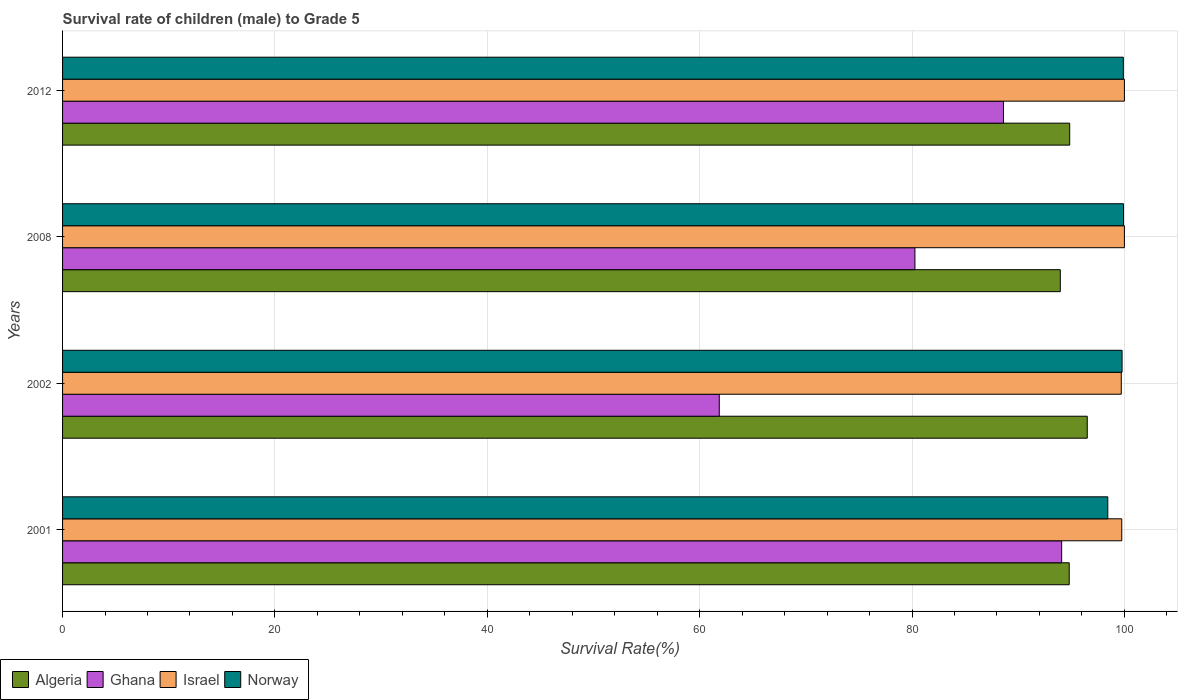Are the number of bars per tick equal to the number of legend labels?
Offer a terse response. Yes. How many bars are there on the 1st tick from the top?
Offer a very short reply. 4. How many bars are there on the 2nd tick from the bottom?
Keep it short and to the point. 4. In how many cases, is the number of bars for a given year not equal to the number of legend labels?
Your response must be concise. 0. What is the survival rate of male children to grade 5 in Norway in 2012?
Keep it short and to the point. 99.9. Across all years, what is the maximum survival rate of male children to grade 5 in Algeria?
Your response must be concise. 96.5. Across all years, what is the minimum survival rate of male children to grade 5 in Israel?
Give a very brief answer. 99.71. What is the total survival rate of male children to grade 5 in Israel in the graph?
Keep it short and to the point. 399.46. What is the difference between the survival rate of male children to grade 5 in Israel in 2008 and that in 2012?
Offer a very short reply. 0. What is the difference between the survival rate of male children to grade 5 in Norway in 2001 and the survival rate of male children to grade 5 in Ghana in 2012?
Provide a succinct answer. 9.83. What is the average survival rate of male children to grade 5 in Ghana per year?
Keep it short and to the point. 81.21. In the year 2008, what is the difference between the survival rate of male children to grade 5 in Ghana and survival rate of male children to grade 5 in Norway?
Provide a succinct answer. -19.65. In how many years, is the survival rate of male children to grade 5 in Algeria greater than 16 %?
Offer a very short reply. 4. What is the ratio of the survival rate of male children to grade 5 in Ghana in 2001 to that in 2002?
Offer a terse response. 1.52. Is the survival rate of male children to grade 5 in Ghana in 2001 less than that in 2002?
Ensure brevity in your answer.  No. What is the difference between the highest and the second highest survival rate of male children to grade 5 in Ghana?
Provide a short and direct response. 5.48. What is the difference between the highest and the lowest survival rate of male children to grade 5 in Algeria?
Offer a terse response. 2.54. Is it the case that in every year, the sum of the survival rate of male children to grade 5 in Algeria and survival rate of male children to grade 5 in Israel is greater than the sum of survival rate of male children to grade 5 in Norway and survival rate of male children to grade 5 in Ghana?
Keep it short and to the point. No. Is it the case that in every year, the sum of the survival rate of male children to grade 5 in Israel and survival rate of male children to grade 5 in Norway is greater than the survival rate of male children to grade 5 in Algeria?
Offer a very short reply. Yes. How many years are there in the graph?
Provide a succinct answer. 4. What is the difference between two consecutive major ticks on the X-axis?
Keep it short and to the point. 20. Does the graph contain any zero values?
Your answer should be compact. No. Does the graph contain grids?
Provide a short and direct response. Yes. Where does the legend appear in the graph?
Offer a very short reply. Bottom left. What is the title of the graph?
Your answer should be compact. Survival rate of children (male) to Grade 5. What is the label or title of the X-axis?
Provide a short and direct response. Survival Rate(%). What is the label or title of the Y-axis?
Your answer should be compact. Years. What is the Survival Rate(%) of Algeria in 2001?
Offer a very short reply. 94.8. What is the Survival Rate(%) in Ghana in 2001?
Provide a succinct answer. 94.09. What is the Survival Rate(%) of Israel in 2001?
Give a very brief answer. 99.75. What is the Survival Rate(%) in Norway in 2001?
Offer a terse response. 98.44. What is the Survival Rate(%) in Algeria in 2002?
Your answer should be compact. 96.5. What is the Survival Rate(%) of Ghana in 2002?
Give a very brief answer. 61.85. What is the Survival Rate(%) of Israel in 2002?
Offer a very short reply. 99.71. What is the Survival Rate(%) in Norway in 2002?
Your answer should be very brief. 99.78. What is the Survival Rate(%) in Algeria in 2008?
Your answer should be very brief. 93.96. What is the Survival Rate(%) of Ghana in 2008?
Keep it short and to the point. 80.27. What is the Survival Rate(%) of Norway in 2008?
Provide a short and direct response. 99.92. What is the Survival Rate(%) in Algeria in 2012?
Your answer should be compact. 94.85. What is the Survival Rate(%) in Ghana in 2012?
Provide a succinct answer. 88.61. What is the Survival Rate(%) of Norway in 2012?
Ensure brevity in your answer.  99.9. Across all years, what is the maximum Survival Rate(%) in Algeria?
Your answer should be very brief. 96.5. Across all years, what is the maximum Survival Rate(%) of Ghana?
Provide a succinct answer. 94.09. Across all years, what is the maximum Survival Rate(%) in Israel?
Give a very brief answer. 100. Across all years, what is the maximum Survival Rate(%) in Norway?
Offer a terse response. 99.92. Across all years, what is the minimum Survival Rate(%) in Algeria?
Provide a short and direct response. 93.96. Across all years, what is the minimum Survival Rate(%) of Ghana?
Make the answer very short. 61.85. Across all years, what is the minimum Survival Rate(%) in Israel?
Ensure brevity in your answer.  99.71. Across all years, what is the minimum Survival Rate(%) of Norway?
Your answer should be compact. 98.44. What is the total Survival Rate(%) of Algeria in the graph?
Provide a succinct answer. 380.12. What is the total Survival Rate(%) of Ghana in the graph?
Offer a terse response. 324.82. What is the total Survival Rate(%) in Israel in the graph?
Make the answer very short. 399.46. What is the total Survival Rate(%) in Norway in the graph?
Offer a terse response. 398.04. What is the difference between the Survival Rate(%) in Algeria in 2001 and that in 2002?
Your answer should be very brief. -1.7. What is the difference between the Survival Rate(%) of Ghana in 2001 and that in 2002?
Provide a short and direct response. 32.24. What is the difference between the Survival Rate(%) of Israel in 2001 and that in 2002?
Your answer should be compact. 0.05. What is the difference between the Survival Rate(%) of Norway in 2001 and that in 2002?
Give a very brief answer. -1.34. What is the difference between the Survival Rate(%) of Algeria in 2001 and that in 2008?
Offer a terse response. 0.84. What is the difference between the Survival Rate(%) of Ghana in 2001 and that in 2008?
Provide a succinct answer. 13.82. What is the difference between the Survival Rate(%) of Israel in 2001 and that in 2008?
Keep it short and to the point. -0.25. What is the difference between the Survival Rate(%) of Norway in 2001 and that in 2008?
Ensure brevity in your answer.  -1.48. What is the difference between the Survival Rate(%) of Algeria in 2001 and that in 2012?
Your response must be concise. -0.05. What is the difference between the Survival Rate(%) of Ghana in 2001 and that in 2012?
Ensure brevity in your answer.  5.48. What is the difference between the Survival Rate(%) in Israel in 2001 and that in 2012?
Offer a very short reply. -0.25. What is the difference between the Survival Rate(%) in Norway in 2001 and that in 2012?
Give a very brief answer. -1.46. What is the difference between the Survival Rate(%) in Algeria in 2002 and that in 2008?
Your answer should be very brief. 2.54. What is the difference between the Survival Rate(%) in Ghana in 2002 and that in 2008?
Your answer should be compact. -18.42. What is the difference between the Survival Rate(%) of Israel in 2002 and that in 2008?
Make the answer very short. -0.29. What is the difference between the Survival Rate(%) of Norway in 2002 and that in 2008?
Your answer should be compact. -0.14. What is the difference between the Survival Rate(%) of Algeria in 2002 and that in 2012?
Provide a short and direct response. 1.65. What is the difference between the Survival Rate(%) in Ghana in 2002 and that in 2012?
Your answer should be very brief. -26.76. What is the difference between the Survival Rate(%) of Israel in 2002 and that in 2012?
Your answer should be very brief. -0.29. What is the difference between the Survival Rate(%) of Norway in 2002 and that in 2012?
Ensure brevity in your answer.  -0.12. What is the difference between the Survival Rate(%) in Algeria in 2008 and that in 2012?
Provide a short and direct response. -0.89. What is the difference between the Survival Rate(%) of Ghana in 2008 and that in 2012?
Provide a succinct answer. -8.34. What is the difference between the Survival Rate(%) of Norway in 2008 and that in 2012?
Your answer should be compact. 0.02. What is the difference between the Survival Rate(%) in Algeria in 2001 and the Survival Rate(%) in Ghana in 2002?
Provide a short and direct response. 32.96. What is the difference between the Survival Rate(%) of Algeria in 2001 and the Survival Rate(%) of Israel in 2002?
Your answer should be compact. -4.9. What is the difference between the Survival Rate(%) in Algeria in 2001 and the Survival Rate(%) in Norway in 2002?
Make the answer very short. -4.98. What is the difference between the Survival Rate(%) of Ghana in 2001 and the Survival Rate(%) of Israel in 2002?
Provide a short and direct response. -5.61. What is the difference between the Survival Rate(%) in Ghana in 2001 and the Survival Rate(%) in Norway in 2002?
Give a very brief answer. -5.69. What is the difference between the Survival Rate(%) of Israel in 2001 and the Survival Rate(%) of Norway in 2002?
Give a very brief answer. -0.03. What is the difference between the Survival Rate(%) in Algeria in 2001 and the Survival Rate(%) in Ghana in 2008?
Make the answer very short. 14.53. What is the difference between the Survival Rate(%) of Algeria in 2001 and the Survival Rate(%) of Israel in 2008?
Provide a short and direct response. -5.2. What is the difference between the Survival Rate(%) of Algeria in 2001 and the Survival Rate(%) of Norway in 2008?
Provide a succinct answer. -5.11. What is the difference between the Survival Rate(%) of Ghana in 2001 and the Survival Rate(%) of Israel in 2008?
Your response must be concise. -5.91. What is the difference between the Survival Rate(%) in Ghana in 2001 and the Survival Rate(%) in Norway in 2008?
Ensure brevity in your answer.  -5.83. What is the difference between the Survival Rate(%) of Israel in 2001 and the Survival Rate(%) of Norway in 2008?
Ensure brevity in your answer.  -0.17. What is the difference between the Survival Rate(%) of Algeria in 2001 and the Survival Rate(%) of Ghana in 2012?
Provide a succinct answer. 6.19. What is the difference between the Survival Rate(%) of Algeria in 2001 and the Survival Rate(%) of Israel in 2012?
Give a very brief answer. -5.2. What is the difference between the Survival Rate(%) of Algeria in 2001 and the Survival Rate(%) of Norway in 2012?
Ensure brevity in your answer.  -5.1. What is the difference between the Survival Rate(%) of Ghana in 2001 and the Survival Rate(%) of Israel in 2012?
Offer a terse response. -5.91. What is the difference between the Survival Rate(%) of Ghana in 2001 and the Survival Rate(%) of Norway in 2012?
Keep it short and to the point. -5.81. What is the difference between the Survival Rate(%) in Israel in 2001 and the Survival Rate(%) in Norway in 2012?
Offer a terse response. -0.15. What is the difference between the Survival Rate(%) in Algeria in 2002 and the Survival Rate(%) in Ghana in 2008?
Ensure brevity in your answer.  16.23. What is the difference between the Survival Rate(%) of Algeria in 2002 and the Survival Rate(%) of Israel in 2008?
Your answer should be very brief. -3.5. What is the difference between the Survival Rate(%) of Algeria in 2002 and the Survival Rate(%) of Norway in 2008?
Your answer should be very brief. -3.42. What is the difference between the Survival Rate(%) in Ghana in 2002 and the Survival Rate(%) in Israel in 2008?
Keep it short and to the point. -38.15. What is the difference between the Survival Rate(%) in Ghana in 2002 and the Survival Rate(%) in Norway in 2008?
Ensure brevity in your answer.  -38.07. What is the difference between the Survival Rate(%) of Israel in 2002 and the Survival Rate(%) of Norway in 2008?
Offer a terse response. -0.21. What is the difference between the Survival Rate(%) of Algeria in 2002 and the Survival Rate(%) of Ghana in 2012?
Keep it short and to the point. 7.89. What is the difference between the Survival Rate(%) of Algeria in 2002 and the Survival Rate(%) of Israel in 2012?
Your response must be concise. -3.5. What is the difference between the Survival Rate(%) of Algeria in 2002 and the Survival Rate(%) of Norway in 2012?
Provide a succinct answer. -3.4. What is the difference between the Survival Rate(%) of Ghana in 2002 and the Survival Rate(%) of Israel in 2012?
Make the answer very short. -38.15. What is the difference between the Survival Rate(%) in Ghana in 2002 and the Survival Rate(%) in Norway in 2012?
Your answer should be very brief. -38.05. What is the difference between the Survival Rate(%) of Israel in 2002 and the Survival Rate(%) of Norway in 2012?
Your response must be concise. -0.19. What is the difference between the Survival Rate(%) in Algeria in 2008 and the Survival Rate(%) in Ghana in 2012?
Keep it short and to the point. 5.35. What is the difference between the Survival Rate(%) in Algeria in 2008 and the Survival Rate(%) in Israel in 2012?
Your response must be concise. -6.04. What is the difference between the Survival Rate(%) of Algeria in 2008 and the Survival Rate(%) of Norway in 2012?
Make the answer very short. -5.94. What is the difference between the Survival Rate(%) of Ghana in 2008 and the Survival Rate(%) of Israel in 2012?
Offer a terse response. -19.73. What is the difference between the Survival Rate(%) of Ghana in 2008 and the Survival Rate(%) of Norway in 2012?
Provide a short and direct response. -19.63. What is the difference between the Survival Rate(%) in Israel in 2008 and the Survival Rate(%) in Norway in 2012?
Give a very brief answer. 0.1. What is the average Survival Rate(%) in Algeria per year?
Make the answer very short. 95.03. What is the average Survival Rate(%) of Ghana per year?
Your answer should be compact. 81.21. What is the average Survival Rate(%) in Israel per year?
Make the answer very short. 99.86. What is the average Survival Rate(%) in Norway per year?
Make the answer very short. 99.51. In the year 2001, what is the difference between the Survival Rate(%) in Algeria and Survival Rate(%) in Ghana?
Offer a very short reply. 0.71. In the year 2001, what is the difference between the Survival Rate(%) of Algeria and Survival Rate(%) of Israel?
Your answer should be compact. -4.95. In the year 2001, what is the difference between the Survival Rate(%) in Algeria and Survival Rate(%) in Norway?
Provide a succinct answer. -3.63. In the year 2001, what is the difference between the Survival Rate(%) of Ghana and Survival Rate(%) of Israel?
Keep it short and to the point. -5.66. In the year 2001, what is the difference between the Survival Rate(%) of Ghana and Survival Rate(%) of Norway?
Your response must be concise. -4.35. In the year 2001, what is the difference between the Survival Rate(%) in Israel and Survival Rate(%) in Norway?
Provide a succinct answer. 1.31. In the year 2002, what is the difference between the Survival Rate(%) in Algeria and Survival Rate(%) in Ghana?
Provide a short and direct response. 34.65. In the year 2002, what is the difference between the Survival Rate(%) of Algeria and Survival Rate(%) of Israel?
Your answer should be very brief. -3.2. In the year 2002, what is the difference between the Survival Rate(%) of Algeria and Survival Rate(%) of Norway?
Give a very brief answer. -3.28. In the year 2002, what is the difference between the Survival Rate(%) of Ghana and Survival Rate(%) of Israel?
Offer a very short reply. -37.86. In the year 2002, what is the difference between the Survival Rate(%) in Ghana and Survival Rate(%) in Norway?
Give a very brief answer. -37.93. In the year 2002, what is the difference between the Survival Rate(%) in Israel and Survival Rate(%) in Norway?
Your answer should be compact. -0.07. In the year 2008, what is the difference between the Survival Rate(%) of Algeria and Survival Rate(%) of Ghana?
Keep it short and to the point. 13.69. In the year 2008, what is the difference between the Survival Rate(%) of Algeria and Survival Rate(%) of Israel?
Offer a very short reply. -6.04. In the year 2008, what is the difference between the Survival Rate(%) in Algeria and Survival Rate(%) in Norway?
Provide a succinct answer. -5.95. In the year 2008, what is the difference between the Survival Rate(%) in Ghana and Survival Rate(%) in Israel?
Offer a very short reply. -19.73. In the year 2008, what is the difference between the Survival Rate(%) in Ghana and Survival Rate(%) in Norway?
Offer a terse response. -19.65. In the year 2008, what is the difference between the Survival Rate(%) of Israel and Survival Rate(%) of Norway?
Provide a succinct answer. 0.08. In the year 2012, what is the difference between the Survival Rate(%) of Algeria and Survival Rate(%) of Ghana?
Your answer should be very brief. 6.24. In the year 2012, what is the difference between the Survival Rate(%) of Algeria and Survival Rate(%) of Israel?
Your response must be concise. -5.15. In the year 2012, what is the difference between the Survival Rate(%) in Algeria and Survival Rate(%) in Norway?
Your response must be concise. -5.05. In the year 2012, what is the difference between the Survival Rate(%) of Ghana and Survival Rate(%) of Israel?
Your response must be concise. -11.39. In the year 2012, what is the difference between the Survival Rate(%) of Ghana and Survival Rate(%) of Norway?
Offer a very short reply. -11.29. In the year 2012, what is the difference between the Survival Rate(%) of Israel and Survival Rate(%) of Norway?
Make the answer very short. 0.1. What is the ratio of the Survival Rate(%) of Algeria in 2001 to that in 2002?
Your answer should be very brief. 0.98. What is the ratio of the Survival Rate(%) in Ghana in 2001 to that in 2002?
Your answer should be very brief. 1.52. What is the ratio of the Survival Rate(%) of Norway in 2001 to that in 2002?
Provide a succinct answer. 0.99. What is the ratio of the Survival Rate(%) of Algeria in 2001 to that in 2008?
Offer a very short reply. 1.01. What is the ratio of the Survival Rate(%) in Ghana in 2001 to that in 2008?
Your answer should be very brief. 1.17. What is the ratio of the Survival Rate(%) of Norway in 2001 to that in 2008?
Ensure brevity in your answer.  0.99. What is the ratio of the Survival Rate(%) in Algeria in 2001 to that in 2012?
Give a very brief answer. 1. What is the ratio of the Survival Rate(%) in Ghana in 2001 to that in 2012?
Provide a succinct answer. 1.06. What is the ratio of the Survival Rate(%) in Algeria in 2002 to that in 2008?
Provide a succinct answer. 1.03. What is the ratio of the Survival Rate(%) of Ghana in 2002 to that in 2008?
Provide a short and direct response. 0.77. What is the ratio of the Survival Rate(%) of Israel in 2002 to that in 2008?
Your response must be concise. 1. What is the ratio of the Survival Rate(%) in Norway in 2002 to that in 2008?
Ensure brevity in your answer.  1. What is the ratio of the Survival Rate(%) of Algeria in 2002 to that in 2012?
Offer a very short reply. 1.02. What is the ratio of the Survival Rate(%) in Ghana in 2002 to that in 2012?
Provide a short and direct response. 0.7. What is the ratio of the Survival Rate(%) of Israel in 2002 to that in 2012?
Your answer should be compact. 1. What is the ratio of the Survival Rate(%) of Norway in 2002 to that in 2012?
Keep it short and to the point. 1. What is the ratio of the Survival Rate(%) in Ghana in 2008 to that in 2012?
Make the answer very short. 0.91. What is the ratio of the Survival Rate(%) of Israel in 2008 to that in 2012?
Your response must be concise. 1. What is the difference between the highest and the second highest Survival Rate(%) of Algeria?
Offer a terse response. 1.65. What is the difference between the highest and the second highest Survival Rate(%) of Ghana?
Your response must be concise. 5.48. What is the difference between the highest and the second highest Survival Rate(%) in Norway?
Offer a terse response. 0.02. What is the difference between the highest and the lowest Survival Rate(%) of Algeria?
Provide a short and direct response. 2.54. What is the difference between the highest and the lowest Survival Rate(%) in Ghana?
Provide a short and direct response. 32.24. What is the difference between the highest and the lowest Survival Rate(%) in Israel?
Offer a very short reply. 0.29. What is the difference between the highest and the lowest Survival Rate(%) of Norway?
Provide a short and direct response. 1.48. 